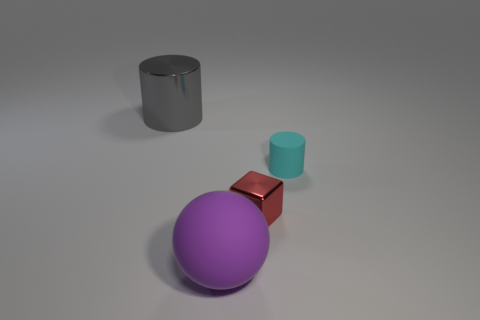There is a cylinder right of the tiny object to the left of the cylinder that is to the right of the tiny red block; what is it made of?
Keep it short and to the point. Rubber. Is the cyan thing the same shape as the large gray object?
Provide a succinct answer. Yes. What is the material of the small cyan thing that is the same shape as the big gray thing?
Your answer should be compact. Rubber. What is the size of the cube that is the same material as the big gray thing?
Make the answer very short. Small. What number of purple things are either matte things or big matte balls?
Keep it short and to the point. 1. What number of purple matte objects are in front of the shiny thing that is left of the big rubber thing?
Ensure brevity in your answer.  1. Are there more large things left of the tiny cylinder than red cubes behind the small red shiny object?
Provide a short and direct response. Yes. What is the ball made of?
Provide a short and direct response. Rubber. Are there any purple rubber spheres that have the same size as the metal cylinder?
Ensure brevity in your answer.  Yes. There is a gray cylinder that is the same size as the purple rubber object; what material is it?
Keep it short and to the point. Metal. 